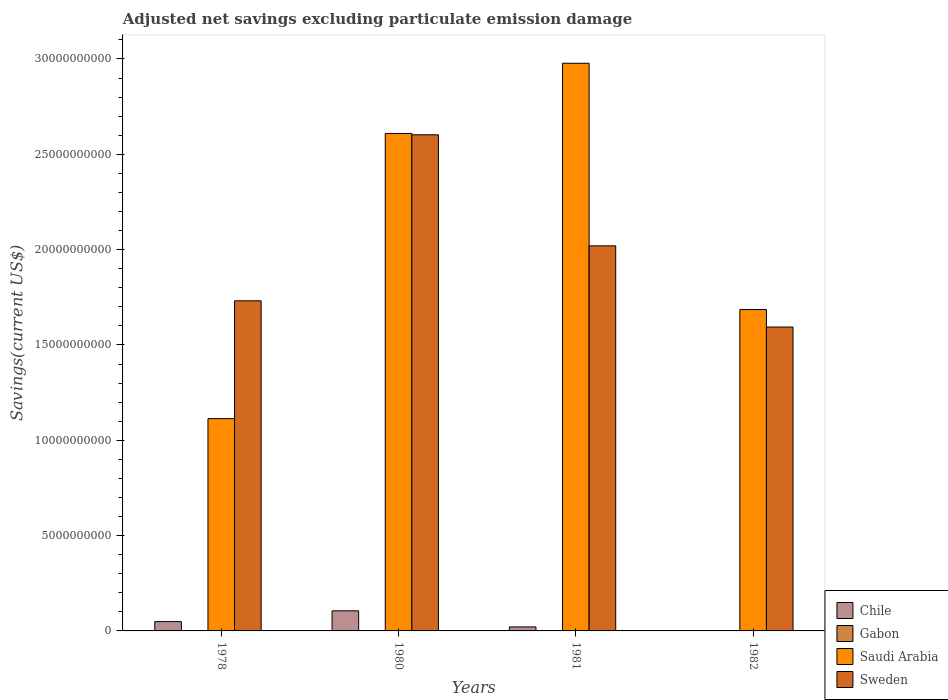How many groups of bars are there?
Offer a very short reply. 4. Are the number of bars per tick equal to the number of legend labels?
Your response must be concise. No. Are the number of bars on each tick of the X-axis equal?
Provide a succinct answer. No. How many bars are there on the 3rd tick from the right?
Make the answer very short. 3. In how many cases, is the number of bars for a given year not equal to the number of legend labels?
Provide a short and direct response. 3. What is the adjusted net savings in Saudi Arabia in 1982?
Keep it short and to the point. 1.69e+1. Across all years, what is the maximum adjusted net savings in Gabon?
Your response must be concise. 2.07e+07. Across all years, what is the minimum adjusted net savings in Sweden?
Your answer should be compact. 1.59e+1. In which year was the adjusted net savings in Gabon maximum?
Your answer should be compact. 1981. What is the total adjusted net savings in Sweden in the graph?
Provide a short and direct response. 7.95e+1. What is the difference between the adjusted net savings in Saudi Arabia in 1980 and that in 1981?
Offer a very short reply. -3.68e+09. What is the difference between the adjusted net savings in Gabon in 1981 and the adjusted net savings in Sweden in 1978?
Your answer should be compact. -1.73e+1. What is the average adjusted net savings in Chile per year?
Offer a very short reply. 4.38e+08. In the year 1978, what is the difference between the adjusted net savings in Chile and adjusted net savings in Saudi Arabia?
Provide a succinct answer. -1.06e+1. What is the ratio of the adjusted net savings in Sweden in 1978 to that in 1981?
Ensure brevity in your answer.  0.86. Is the adjusted net savings in Saudi Arabia in 1980 less than that in 1981?
Offer a terse response. Yes. What is the difference between the highest and the second highest adjusted net savings in Chile?
Ensure brevity in your answer.  5.65e+08. What is the difference between the highest and the lowest adjusted net savings in Gabon?
Make the answer very short. 2.07e+07. In how many years, is the adjusted net savings in Saudi Arabia greater than the average adjusted net savings in Saudi Arabia taken over all years?
Offer a very short reply. 2. Is the sum of the adjusted net savings in Sweden in 1978 and 1982 greater than the maximum adjusted net savings in Saudi Arabia across all years?
Offer a very short reply. Yes. Is it the case that in every year, the sum of the adjusted net savings in Chile and adjusted net savings in Saudi Arabia is greater than the sum of adjusted net savings in Sweden and adjusted net savings in Gabon?
Keep it short and to the point. No. How many bars are there?
Make the answer very short. 12. Are all the bars in the graph horizontal?
Keep it short and to the point. No. How many years are there in the graph?
Offer a terse response. 4. Are the values on the major ticks of Y-axis written in scientific E-notation?
Ensure brevity in your answer.  No. Does the graph contain grids?
Ensure brevity in your answer.  No. Where does the legend appear in the graph?
Your answer should be very brief. Bottom right. What is the title of the graph?
Keep it short and to the point. Adjusted net savings excluding particulate emission damage. Does "Ethiopia" appear as one of the legend labels in the graph?
Your answer should be compact. No. What is the label or title of the Y-axis?
Your response must be concise. Savings(current US$). What is the Savings(current US$) of Chile in 1978?
Your answer should be compact. 4.88e+08. What is the Savings(current US$) of Gabon in 1978?
Provide a short and direct response. 0. What is the Savings(current US$) of Saudi Arabia in 1978?
Make the answer very short. 1.11e+1. What is the Savings(current US$) of Sweden in 1978?
Offer a terse response. 1.73e+1. What is the Savings(current US$) in Chile in 1980?
Provide a short and direct response. 1.05e+09. What is the Savings(current US$) of Saudi Arabia in 1980?
Provide a succinct answer. 2.61e+1. What is the Savings(current US$) in Sweden in 1980?
Keep it short and to the point. 2.60e+1. What is the Savings(current US$) of Chile in 1981?
Provide a succinct answer. 2.09e+08. What is the Savings(current US$) in Gabon in 1981?
Give a very brief answer. 2.07e+07. What is the Savings(current US$) of Saudi Arabia in 1981?
Offer a very short reply. 2.98e+1. What is the Savings(current US$) of Sweden in 1981?
Your response must be concise. 2.02e+1. What is the Savings(current US$) in Saudi Arabia in 1982?
Your response must be concise. 1.69e+1. What is the Savings(current US$) in Sweden in 1982?
Provide a short and direct response. 1.59e+1. Across all years, what is the maximum Savings(current US$) of Chile?
Offer a terse response. 1.05e+09. Across all years, what is the maximum Savings(current US$) in Gabon?
Provide a succinct answer. 2.07e+07. Across all years, what is the maximum Savings(current US$) in Saudi Arabia?
Give a very brief answer. 2.98e+1. Across all years, what is the maximum Savings(current US$) in Sweden?
Ensure brevity in your answer.  2.60e+1. Across all years, what is the minimum Savings(current US$) in Chile?
Offer a terse response. 0. Across all years, what is the minimum Savings(current US$) of Saudi Arabia?
Keep it short and to the point. 1.11e+1. Across all years, what is the minimum Savings(current US$) in Sweden?
Offer a terse response. 1.59e+1. What is the total Savings(current US$) of Chile in the graph?
Your answer should be compact. 1.75e+09. What is the total Savings(current US$) in Gabon in the graph?
Your response must be concise. 2.07e+07. What is the total Savings(current US$) of Saudi Arabia in the graph?
Offer a terse response. 8.39e+1. What is the total Savings(current US$) of Sweden in the graph?
Offer a very short reply. 7.95e+1. What is the difference between the Savings(current US$) in Chile in 1978 and that in 1980?
Your response must be concise. -5.65e+08. What is the difference between the Savings(current US$) in Saudi Arabia in 1978 and that in 1980?
Make the answer very short. -1.50e+1. What is the difference between the Savings(current US$) in Sweden in 1978 and that in 1980?
Offer a terse response. -8.71e+09. What is the difference between the Savings(current US$) of Chile in 1978 and that in 1981?
Provide a succinct answer. 2.79e+08. What is the difference between the Savings(current US$) in Saudi Arabia in 1978 and that in 1981?
Keep it short and to the point. -1.86e+1. What is the difference between the Savings(current US$) in Sweden in 1978 and that in 1981?
Provide a succinct answer. -2.88e+09. What is the difference between the Savings(current US$) in Saudi Arabia in 1978 and that in 1982?
Your response must be concise. -5.72e+09. What is the difference between the Savings(current US$) of Sweden in 1978 and that in 1982?
Provide a short and direct response. 1.37e+09. What is the difference between the Savings(current US$) in Chile in 1980 and that in 1981?
Keep it short and to the point. 8.44e+08. What is the difference between the Savings(current US$) in Saudi Arabia in 1980 and that in 1981?
Provide a short and direct response. -3.68e+09. What is the difference between the Savings(current US$) in Sweden in 1980 and that in 1981?
Provide a short and direct response. 5.82e+09. What is the difference between the Savings(current US$) in Saudi Arabia in 1980 and that in 1982?
Your response must be concise. 9.23e+09. What is the difference between the Savings(current US$) in Sweden in 1980 and that in 1982?
Ensure brevity in your answer.  1.01e+1. What is the difference between the Savings(current US$) of Saudi Arabia in 1981 and that in 1982?
Your answer should be very brief. 1.29e+1. What is the difference between the Savings(current US$) of Sweden in 1981 and that in 1982?
Your response must be concise. 4.26e+09. What is the difference between the Savings(current US$) in Chile in 1978 and the Savings(current US$) in Saudi Arabia in 1980?
Give a very brief answer. -2.56e+1. What is the difference between the Savings(current US$) of Chile in 1978 and the Savings(current US$) of Sweden in 1980?
Offer a very short reply. -2.55e+1. What is the difference between the Savings(current US$) of Saudi Arabia in 1978 and the Savings(current US$) of Sweden in 1980?
Offer a terse response. -1.49e+1. What is the difference between the Savings(current US$) of Chile in 1978 and the Savings(current US$) of Gabon in 1981?
Provide a short and direct response. 4.68e+08. What is the difference between the Savings(current US$) in Chile in 1978 and the Savings(current US$) in Saudi Arabia in 1981?
Offer a terse response. -2.93e+1. What is the difference between the Savings(current US$) in Chile in 1978 and the Savings(current US$) in Sweden in 1981?
Ensure brevity in your answer.  -1.97e+1. What is the difference between the Savings(current US$) of Saudi Arabia in 1978 and the Savings(current US$) of Sweden in 1981?
Your answer should be compact. -9.06e+09. What is the difference between the Savings(current US$) of Chile in 1978 and the Savings(current US$) of Saudi Arabia in 1982?
Provide a short and direct response. -1.64e+1. What is the difference between the Savings(current US$) in Chile in 1978 and the Savings(current US$) in Sweden in 1982?
Your answer should be very brief. -1.55e+1. What is the difference between the Savings(current US$) in Saudi Arabia in 1978 and the Savings(current US$) in Sweden in 1982?
Offer a terse response. -4.80e+09. What is the difference between the Savings(current US$) in Chile in 1980 and the Savings(current US$) in Gabon in 1981?
Your answer should be very brief. 1.03e+09. What is the difference between the Savings(current US$) of Chile in 1980 and the Savings(current US$) of Saudi Arabia in 1981?
Make the answer very short. -2.87e+1. What is the difference between the Savings(current US$) of Chile in 1980 and the Savings(current US$) of Sweden in 1981?
Provide a short and direct response. -1.91e+1. What is the difference between the Savings(current US$) in Saudi Arabia in 1980 and the Savings(current US$) in Sweden in 1981?
Offer a terse response. 5.89e+09. What is the difference between the Savings(current US$) of Chile in 1980 and the Savings(current US$) of Saudi Arabia in 1982?
Your answer should be compact. -1.58e+1. What is the difference between the Savings(current US$) of Chile in 1980 and the Savings(current US$) of Sweden in 1982?
Offer a very short reply. -1.49e+1. What is the difference between the Savings(current US$) of Saudi Arabia in 1980 and the Savings(current US$) of Sweden in 1982?
Provide a succinct answer. 1.02e+1. What is the difference between the Savings(current US$) of Chile in 1981 and the Savings(current US$) of Saudi Arabia in 1982?
Provide a short and direct response. -1.66e+1. What is the difference between the Savings(current US$) in Chile in 1981 and the Savings(current US$) in Sweden in 1982?
Ensure brevity in your answer.  -1.57e+1. What is the difference between the Savings(current US$) in Gabon in 1981 and the Savings(current US$) in Saudi Arabia in 1982?
Provide a short and direct response. -1.68e+1. What is the difference between the Savings(current US$) in Gabon in 1981 and the Savings(current US$) in Sweden in 1982?
Your response must be concise. -1.59e+1. What is the difference between the Savings(current US$) of Saudi Arabia in 1981 and the Savings(current US$) of Sweden in 1982?
Provide a short and direct response. 1.38e+1. What is the average Savings(current US$) in Chile per year?
Offer a very short reply. 4.38e+08. What is the average Savings(current US$) of Gabon per year?
Your response must be concise. 5.18e+06. What is the average Savings(current US$) in Saudi Arabia per year?
Make the answer very short. 2.10e+1. What is the average Savings(current US$) in Sweden per year?
Your answer should be compact. 1.99e+1. In the year 1978, what is the difference between the Savings(current US$) in Chile and Savings(current US$) in Saudi Arabia?
Provide a succinct answer. -1.06e+1. In the year 1978, what is the difference between the Savings(current US$) of Chile and Savings(current US$) of Sweden?
Make the answer very short. -1.68e+1. In the year 1978, what is the difference between the Savings(current US$) of Saudi Arabia and Savings(current US$) of Sweden?
Ensure brevity in your answer.  -6.18e+09. In the year 1980, what is the difference between the Savings(current US$) of Chile and Savings(current US$) of Saudi Arabia?
Your answer should be very brief. -2.50e+1. In the year 1980, what is the difference between the Savings(current US$) of Chile and Savings(current US$) of Sweden?
Keep it short and to the point. -2.50e+1. In the year 1980, what is the difference between the Savings(current US$) of Saudi Arabia and Savings(current US$) of Sweden?
Offer a terse response. 6.97e+07. In the year 1981, what is the difference between the Savings(current US$) in Chile and Savings(current US$) in Gabon?
Offer a terse response. 1.88e+08. In the year 1981, what is the difference between the Savings(current US$) in Chile and Savings(current US$) in Saudi Arabia?
Your response must be concise. -2.96e+1. In the year 1981, what is the difference between the Savings(current US$) of Chile and Savings(current US$) of Sweden?
Provide a succinct answer. -2.00e+1. In the year 1981, what is the difference between the Savings(current US$) of Gabon and Savings(current US$) of Saudi Arabia?
Provide a succinct answer. -2.98e+1. In the year 1981, what is the difference between the Savings(current US$) of Gabon and Savings(current US$) of Sweden?
Ensure brevity in your answer.  -2.02e+1. In the year 1981, what is the difference between the Savings(current US$) of Saudi Arabia and Savings(current US$) of Sweden?
Your answer should be compact. 9.58e+09. In the year 1982, what is the difference between the Savings(current US$) of Saudi Arabia and Savings(current US$) of Sweden?
Ensure brevity in your answer.  9.18e+08. What is the ratio of the Savings(current US$) of Chile in 1978 to that in 1980?
Your response must be concise. 0.46. What is the ratio of the Savings(current US$) of Saudi Arabia in 1978 to that in 1980?
Give a very brief answer. 0.43. What is the ratio of the Savings(current US$) of Sweden in 1978 to that in 1980?
Your response must be concise. 0.67. What is the ratio of the Savings(current US$) of Chile in 1978 to that in 1981?
Provide a short and direct response. 2.34. What is the ratio of the Savings(current US$) of Saudi Arabia in 1978 to that in 1981?
Provide a short and direct response. 0.37. What is the ratio of the Savings(current US$) of Sweden in 1978 to that in 1981?
Make the answer very short. 0.86. What is the ratio of the Savings(current US$) in Saudi Arabia in 1978 to that in 1982?
Ensure brevity in your answer.  0.66. What is the ratio of the Savings(current US$) in Sweden in 1978 to that in 1982?
Give a very brief answer. 1.09. What is the ratio of the Savings(current US$) in Chile in 1980 to that in 1981?
Your answer should be very brief. 5.04. What is the ratio of the Savings(current US$) in Saudi Arabia in 1980 to that in 1981?
Offer a terse response. 0.88. What is the ratio of the Savings(current US$) in Sweden in 1980 to that in 1981?
Keep it short and to the point. 1.29. What is the ratio of the Savings(current US$) in Saudi Arabia in 1980 to that in 1982?
Make the answer very short. 1.55. What is the ratio of the Savings(current US$) of Sweden in 1980 to that in 1982?
Offer a very short reply. 1.63. What is the ratio of the Savings(current US$) in Saudi Arabia in 1981 to that in 1982?
Provide a short and direct response. 1.77. What is the ratio of the Savings(current US$) of Sweden in 1981 to that in 1982?
Your answer should be compact. 1.27. What is the difference between the highest and the second highest Savings(current US$) of Chile?
Offer a very short reply. 5.65e+08. What is the difference between the highest and the second highest Savings(current US$) in Saudi Arabia?
Your answer should be very brief. 3.68e+09. What is the difference between the highest and the second highest Savings(current US$) in Sweden?
Offer a very short reply. 5.82e+09. What is the difference between the highest and the lowest Savings(current US$) in Chile?
Ensure brevity in your answer.  1.05e+09. What is the difference between the highest and the lowest Savings(current US$) in Gabon?
Keep it short and to the point. 2.07e+07. What is the difference between the highest and the lowest Savings(current US$) of Saudi Arabia?
Keep it short and to the point. 1.86e+1. What is the difference between the highest and the lowest Savings(current US$) of Sweden?
Provide a short and direct response. 1.01e+1. 